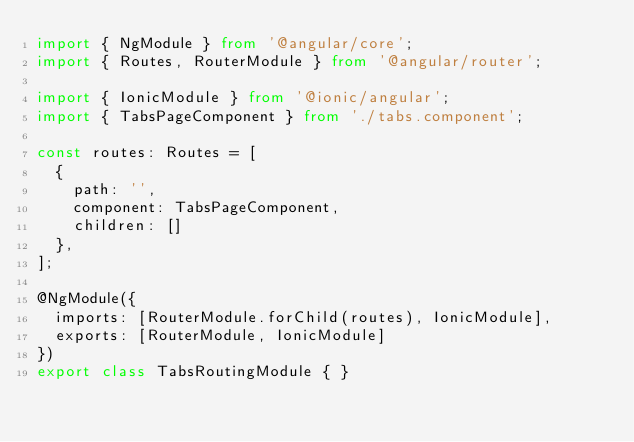Convert code to text. <code><loc_0><loc_0><loc_500><loc_500><_TypeScript_>import { NgModule } from '@angular/core';
import { Routes, RouterModule } from '@angular/router';

import { IonicModule } from '@ionic/angular';
import { TabsPageComponent } from './tabs.component';

const routes: Routes = [
  {
    path: '',
    component: TabsPageComponent,
    children: []
  },
];

@NgModule({
  imports: [RouterModule.forChild(routes), IonicModule],
  exports: [RouterModule, IonicModule]
})
export class TabsRoutingModule { }
</code> 